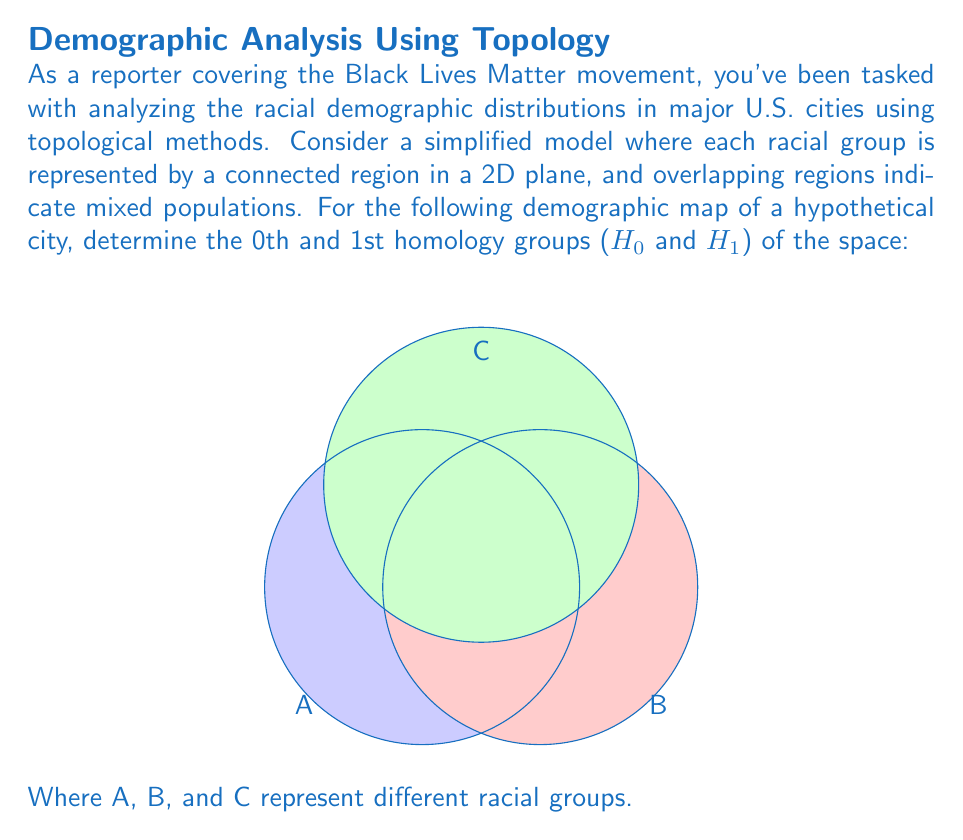What is the answer to this math problem? To determine the homology groups, we need to analyze the topological features of the space:

1. Connected components (0th homology group, $$H_0$$):
   The entire space is connected, as all regions overlap. This means there is only one connected component.
   $$\text{rank}(H_0) = 1$$

2. Holes (1st homology group, $$H_1$$):
   The overlapping regions create two distinct holes in the space. These holes are not filled by any other region.
   $$\text{rank}(H_1) = 2$$

3. Higher-dimensional features:
   Since this is a 2D representation, there are no higher-dimensional features to consider.

Therefore, we can express the homology groups as:

$$H_0 \cong \mathbb{Z}$$
$$H_1 \cong \mathbb{Z} \oplus \mathbb{Z}$$
$$H_n \cong 0 \text{ for } n \geq 2$$

Where $$\mathbb{Z}$$ represents the group of integers under addition, and $$\oplus$$ denotes the direct sum of groups.
Answer: $$H_0 \cong \mathbb{Z}, H_1 \cong \mathbb{Z} \oplus \mathbb{Z}, H_n \cong 0 \text{ for } n \geq 2$$ 